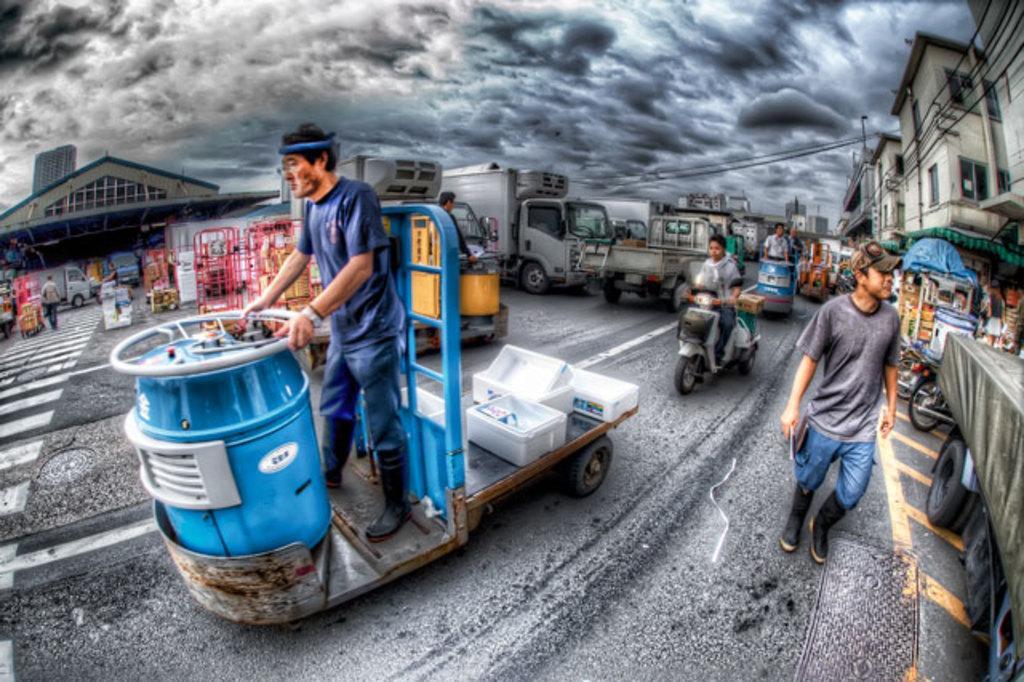How would you summarize this image in a sentence or two? In this image I can see a crowd and vehicles on the road. In the background I can see buildings, wires and poles. On the top I can see the sky. This image is taken during a day on the road. 